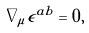Convert formula to latex. <formula><loc_0><loc_0><loc_500><loc_500>\nabla _ { \mu } \epsilon ^ { a b } = 0 ,</formula> 